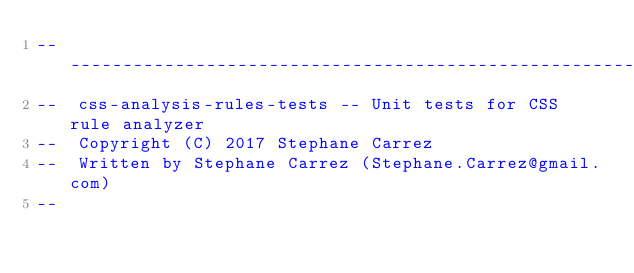Convert code to text. <code><loc_0><loc_0><loc_500><loc_500><_Ada_>-----------------------------------------------------------------------
--  css-analysis-rules-tests -- Unit tests for CSS rule analyzer
--  Copyright (C) 2017 Stephane Carrez
--  Written by Stephane Carrez (Stephane.Carrez@gmail.com)
--</code> 